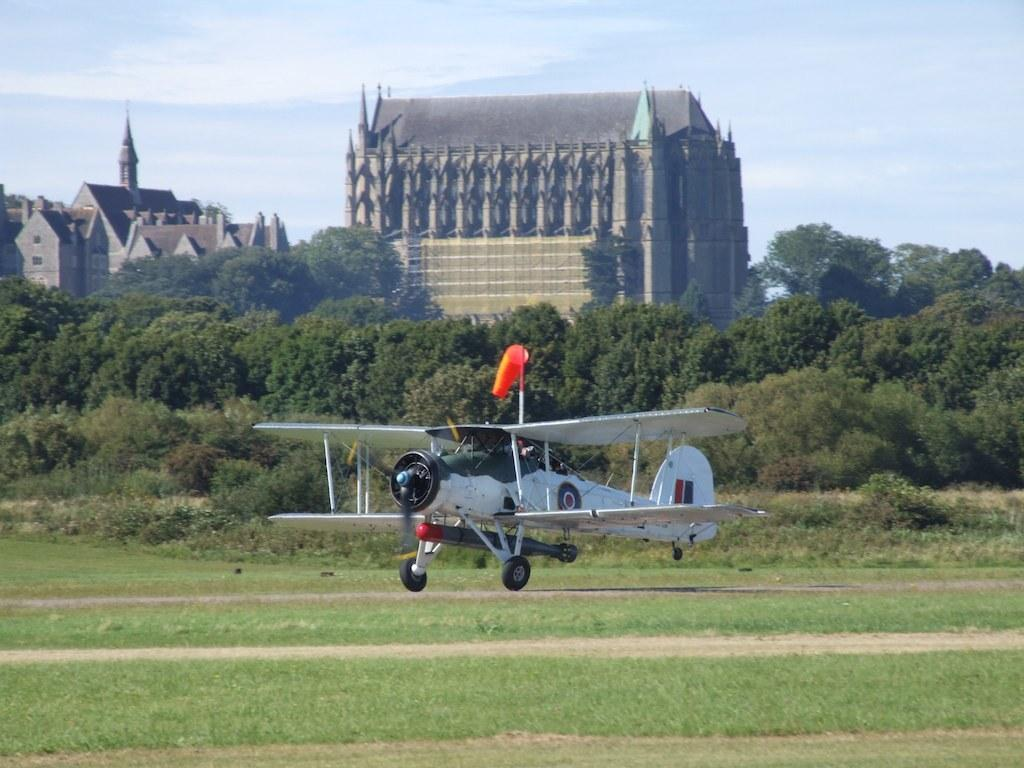What is the main subject of the image? There is a plane on a pathway in the image. What type of natural environment is visible in the image? There is grass and trees visible in the image. What type of structures can be seen in the background of the image? There are houses with roofs in the background of the image. How would you describe the sky in the image? The sky is visible in the image and appears cloudy. Can you see any pests crawling on the plane in the image? There are no pests visible in the image, as it primarily features a plane on a pathway, grass, trees, houses, and a cloudy sky. 